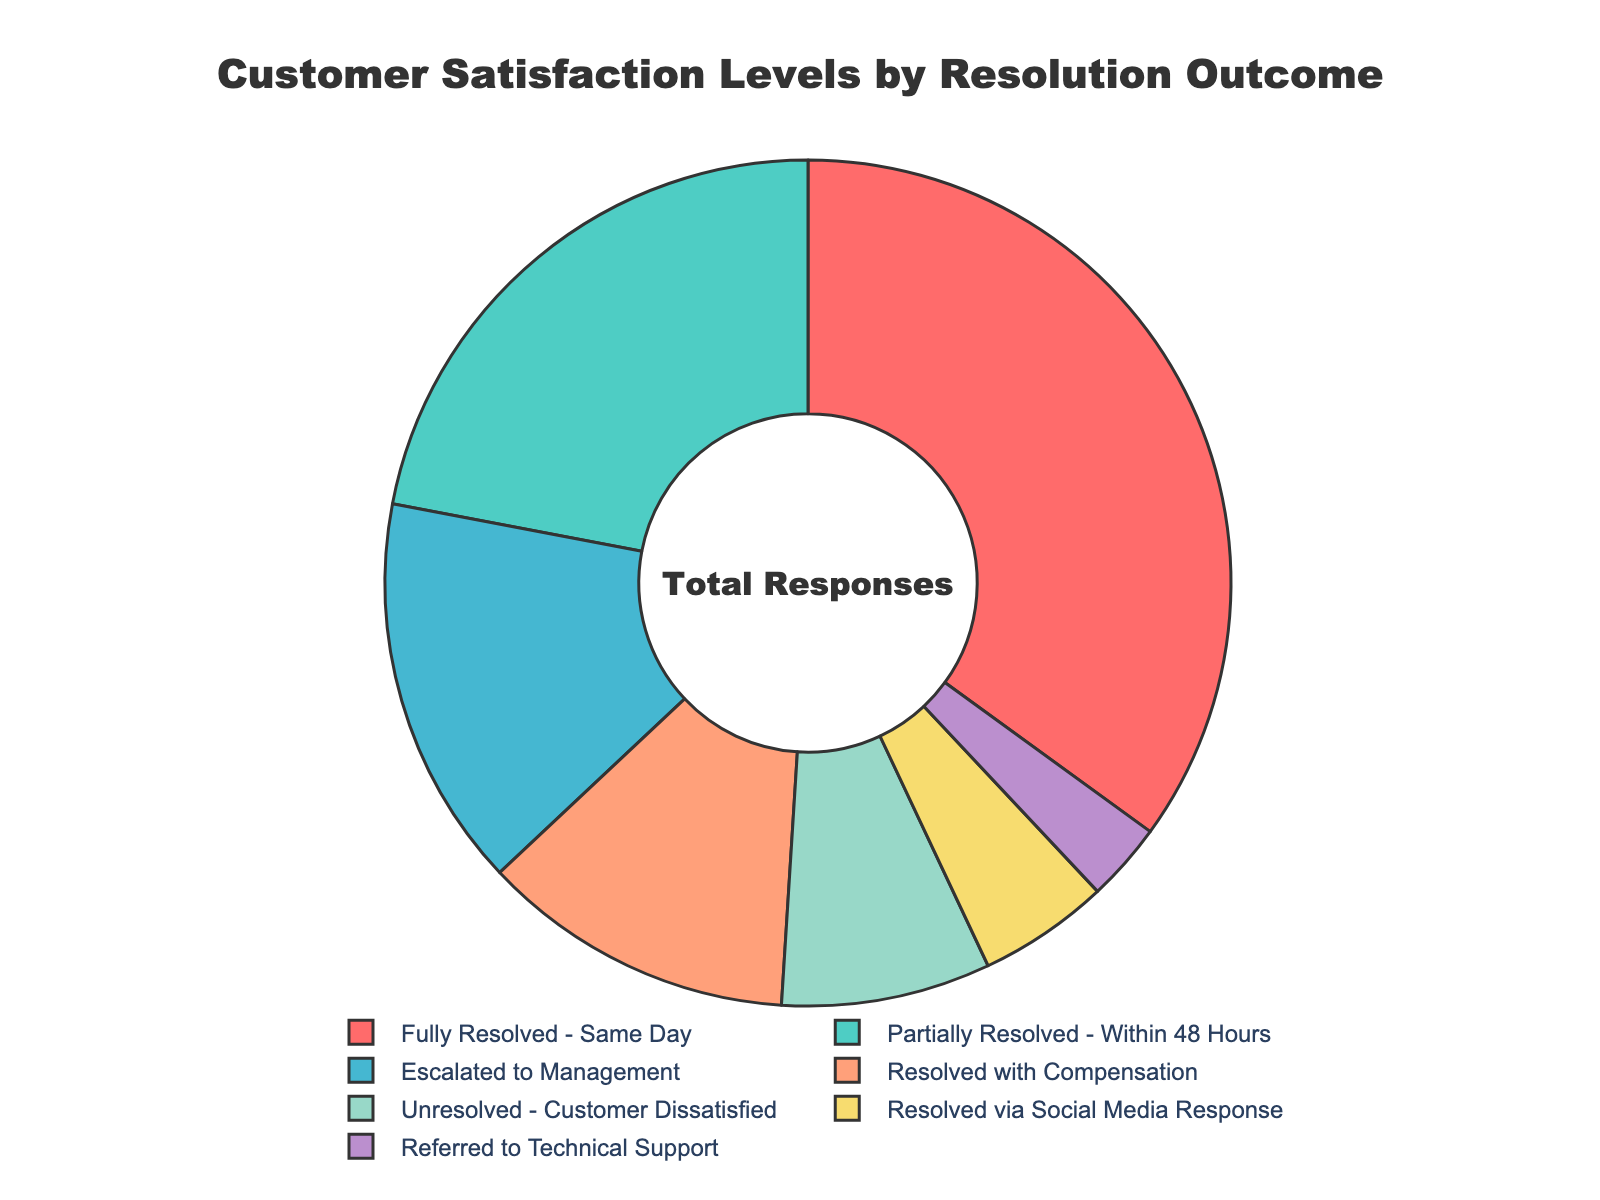What's the percentage of complaints fully resolved on the same day? Look for the segment labeled "Fully Resolved - Same Day" and note its percentage. It shows 35%.
Answer: 35% What is the total percentage of complaints either fully resolved on the same day or referred to technical support? Add the percentages for the segments labeled "Fully Resolved - Same Day" (35%) and "Referred to Technical Support" (3%). The sum is 35% + 3% = 38%.
Answer: 38% Which resolution outcome has a higher percentage, "Partially Resolved - Within 48 Hours" or "Escalated to Management"? Compare the percentages of the segments labeled "Partially Resolved - Within 48 Hours" (22%) and "Escalated to Management" (15%). 22% is higher than 15%.
Answer: Partially Resolved - Within 48 Hours What is the difference in percentage between "Resolved with Compensation" and "Unresolved - Customer Dissatisfied"? Subtract the percentage of "Unresolved - Customer Dissatisfied" (8%) from the percentage of "Resolved with Compensation" (12%). The difference is 12% - 8% = 4%.
Answer: 4% If you combine the percentages of "Escalated to Management" and "Unresolved - Customer Dissatisfied," what is the result? Add the percentages for "Escalated to Management" (15%) and "Unresolved - Customer Dissatisfied" (8%). The sum is 15% + 8% = 23%.
Answer: 23% Which resolution outcome has the smallest segment on the pie chart? Identify the segment with the smallest percentage. "Referred to Technical Support" has 3%, the smallest percentage.
Answer: Referred to Technical Support How many resolution outcomes have a percentage greater than 10%? Count the number of segments with a percentage above 10%. They are "Fully Resolved - Same Day" (35%), "Partially Resolved - Within 48 Hours" (22%), "Escalated to Management" (15%), and "Resolved with Compensation" (12%). This totals 4 segments.
Answer: 4 What is the combined percentage of resolution outcomes labeled "Resolved via Social Media Response" and "Referred to Technical Support"? Add the percentages for "Resolved via Social Media Response" (5%) and "Referred to Technical Support" (3%). The sum is 5% + 3% = 8%.
Answer: 8% What percentage of complaints are either unresolved or required compensation? Add the percentages for "Unresolved - Customer Dissatisfied" (8%) and "Resolved with Compensation" (12%). The sum is 8% + 12% = 20%.
Answer: 20% How does the percentage of "Escalated to Management" compare to the "Resolved via Social Media Response"? Compare the percentages of "Escalated to Management" (15%) and "Resolved via Social Media Response" (5%). 15% is greater than 5%.
Answer: Escalated to Management is greater 